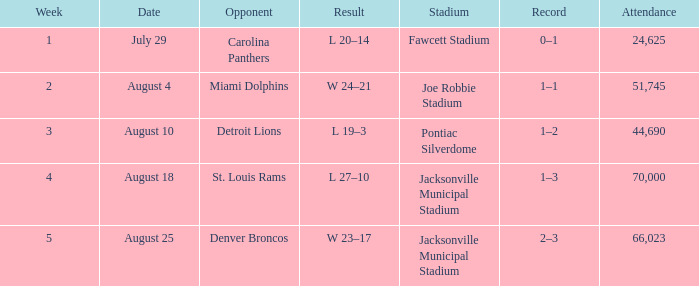WHEN has a Result of w 23–17? August 25. 